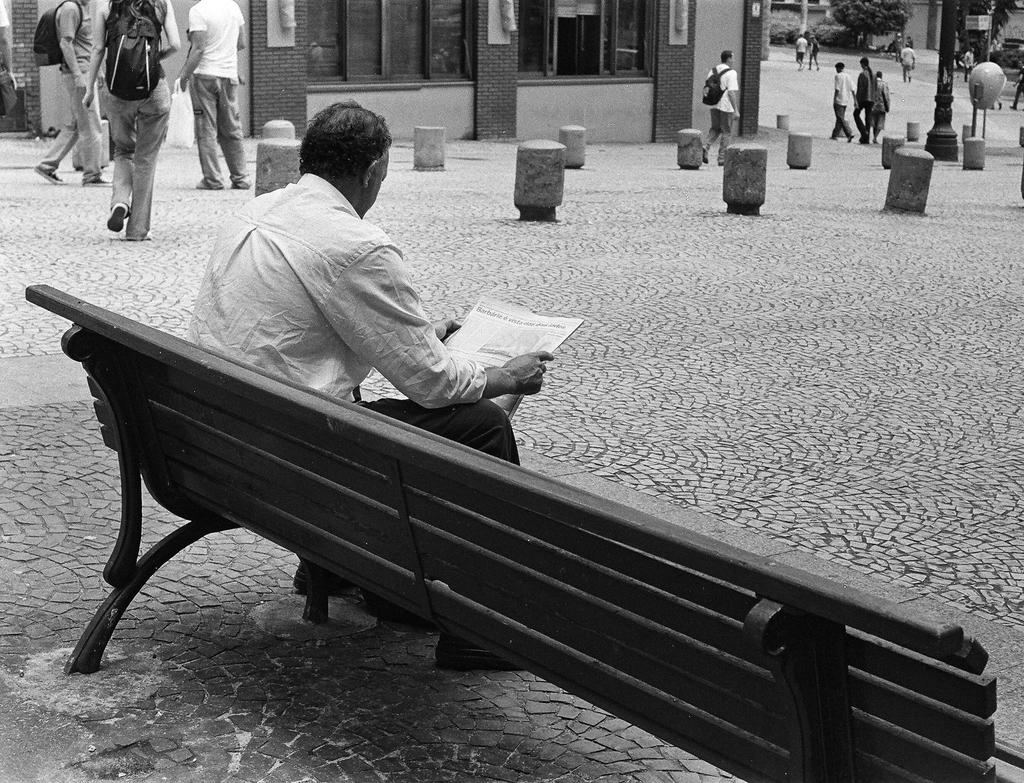What is the person in the image doing while sitting on the bench? The person is reading a newspaper. What can be seen in the background of the image? There are people walking on the road and buildings visible in the background of the image. What type of vegetation is present in the background of the image? There are trees present in the background of the image. What type of ship can be seen sailing in the background of the image? There is no ship present in the image; it features a person sitting on a bench reading a newspaper, with people walking, buildings, and trees in the background. 